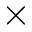Convert formula to latex. <formula><loc_0><loc_0><loc_500><loc_500>\times</formula> 